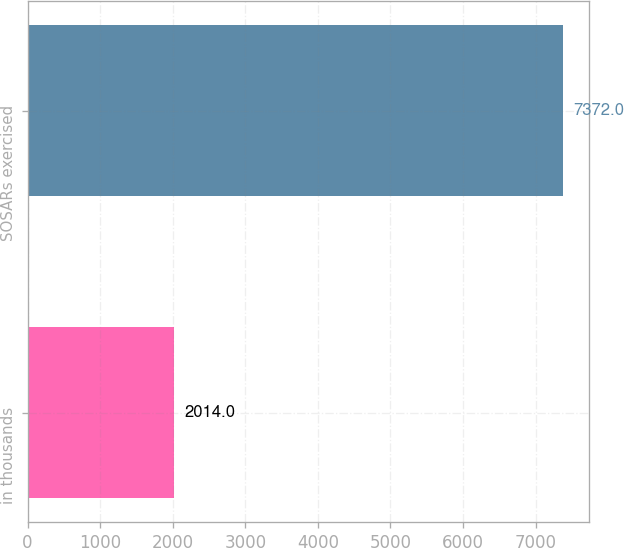Convert chart. <chart><loc_0><loc_0><loc_500><loc_500><bar_chart><fcel>in thousands<fcel>SOSARs exercised<nl><fcel>2014<fcel>7372<nl></chart> 